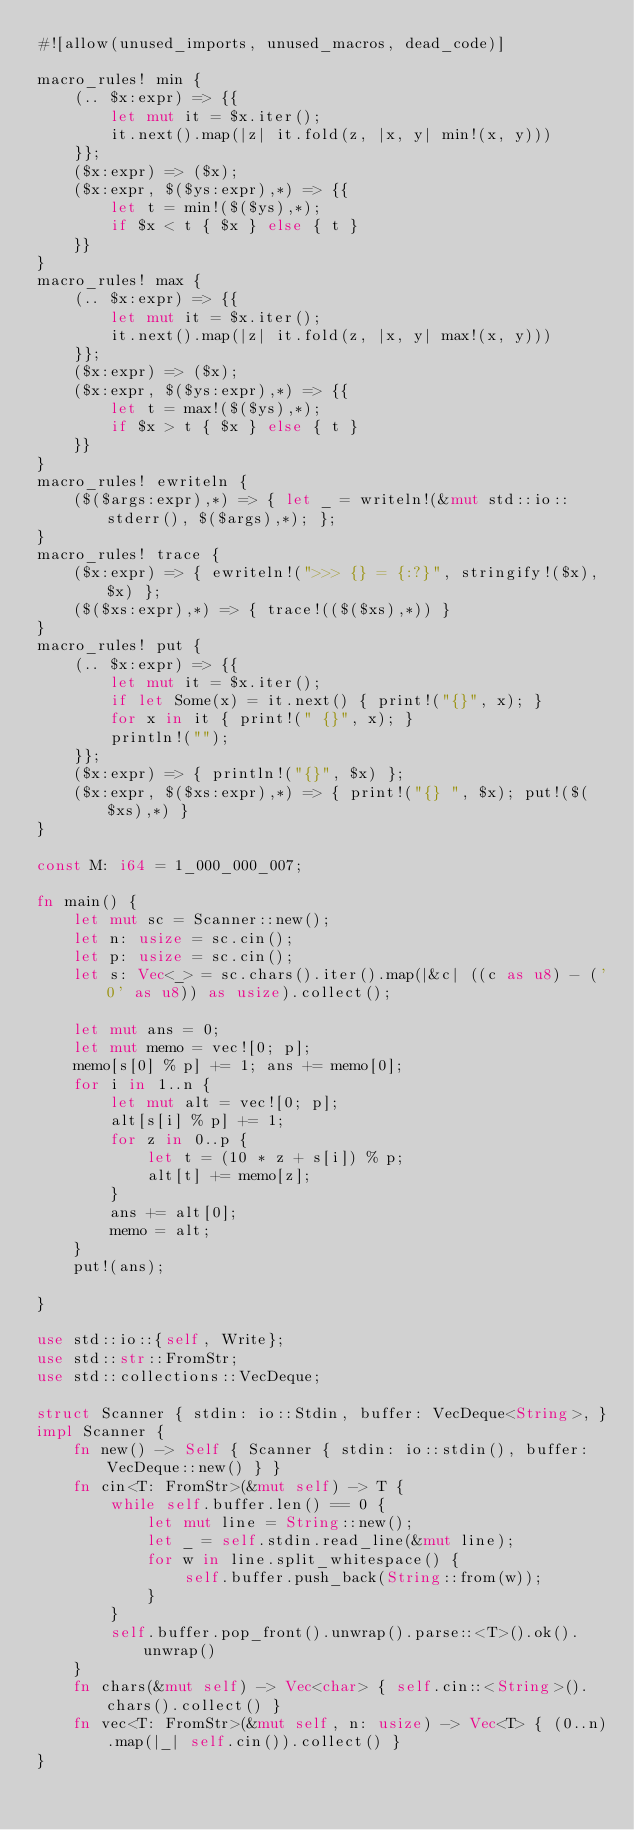Convert code to text. <code><loc_0><loc_0><loc_500><loc_500><_Rust_>#![allow(unused_imports, unused_macros, dead_code)]

macro_rules! min {
    (.. $x:expr) => {{
        let mut it = $x.iter();
        it.next().map(|z| it.fold(z, |x, y| min!(x, y)))
    }};
    ($x:expr) => ($x);
    ($x:expr, $($ys:expr),*) => {{
        let t = min!($($ys),*);
        if $x < t { $x } else { t }
    }}
}
macro_rules! max {
    (.. $x:expr) => {{
        let mut it = $x.iter();
        it.next().map(|z| it.fold(z, |x, y| max!(x, y)))
    }};
    ($x:expr) => ($x);
    ($x:expr, $($ys:expr),*) => {{
        let t = max!($($ys),*);
        if $x > t { $x } else { t }
    }}
}
macro_rules! ewriteln {
    ($($args:expr),*) => { let _ = writeln!(&mut std::io::stderr(), $($args),*); };
}
macro_rules! trace {
    ($x:expr) => { ewriteln!(">>> {} = {:?}", stringify!($x), $x) };
    ($($xs:expr),*) => { trace!(($($xs),*)) }
}
macro_rules! put {
    (.. $x:expr) => {{
        let mut it = $x.iter();
        if let Some(x) = it.next() { print!("{}", x); }
        for x in it { print!(" {}", x); }
        println!("");
    }};
    ($x:expr) => { println!("{}", $x) };
    ($x:expr, $($xs:expr),*) => { print!("{} ", $x); put!($($xs),*) }
}

const M: i64 = 1_000_000_007;

fn main() {
    let mut sc = Scanner::new();
    let n: usize = sc.cin();
    let p: usize = sc.cin();
    let s: Vec<_> = sc.chars().iter().map(|&c| ((c as u8) - ('0' as u8)) as usize).collect();

    let mut ans = 0;
    let mut memo = vec![0; p];
    memo[s[0] % p] += 1; ans += memo[0];
    for i in 1..n {
        let mut alt = vec![0; p];
        alt[s[i] % p] += 1;
        for z in 0..p {
            let t = (10 * z + s[i]) % p;
            alt[t] += memo[z];
        }
        ans += alt[0];
        memo = alt;
    }
    put!(ans);

}

use std::io::{self, Write};
use std::str::FromStr;
use std::collections::VecDeque;

struct Scanner { stdin: io::Stdin, buffer: VecDeque<String>, }
impl Scanner {
    fn new() -> Self { Scanner { stdin: io::stdin(), buffer: VecDeque::new() } }
    fn cin<T: FromStr>(&mut self) -> T {
        while self.buffer.len() == 0 {
            let mut line = String::new();
            let _ = self.stdin.read_line(&mut line);
            for w in line.split_whitespace() {
                self.buffer.push_back(String::from(w));
            }
        }
        self.buffer.pop_front().unwrap().parse::<T>().ok().unwrap()
    }
    fn chars(&mut self) -> Vec<char> { self.cin::<String>().chars().collect() }
    fn vec<T: FromStr>(&mut self, n: usize) -> Vec<T> { (0..n).map(|_| self.cin()).collect() }
}
</code> 